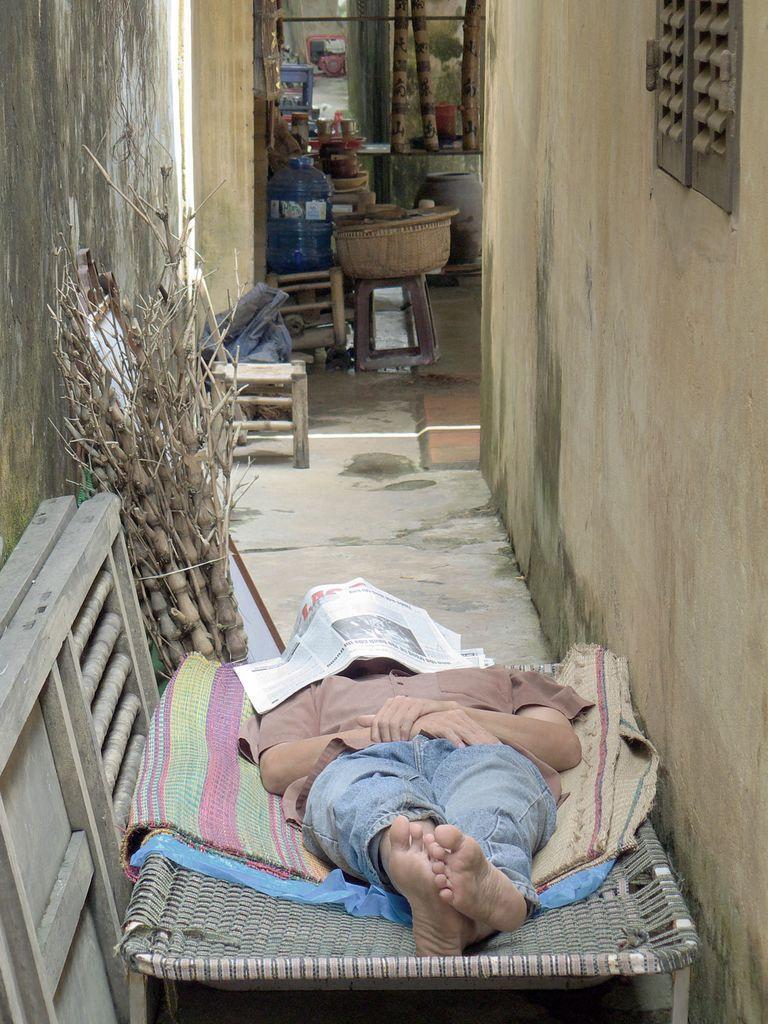Can you describe this image briefly? In this image we can see this person wearing shirt and jeans is lying on the cot by covering their face with newspaper. Here we can see the wall, we can see a few wooden objects, wooden stools and a few more things in the background. 